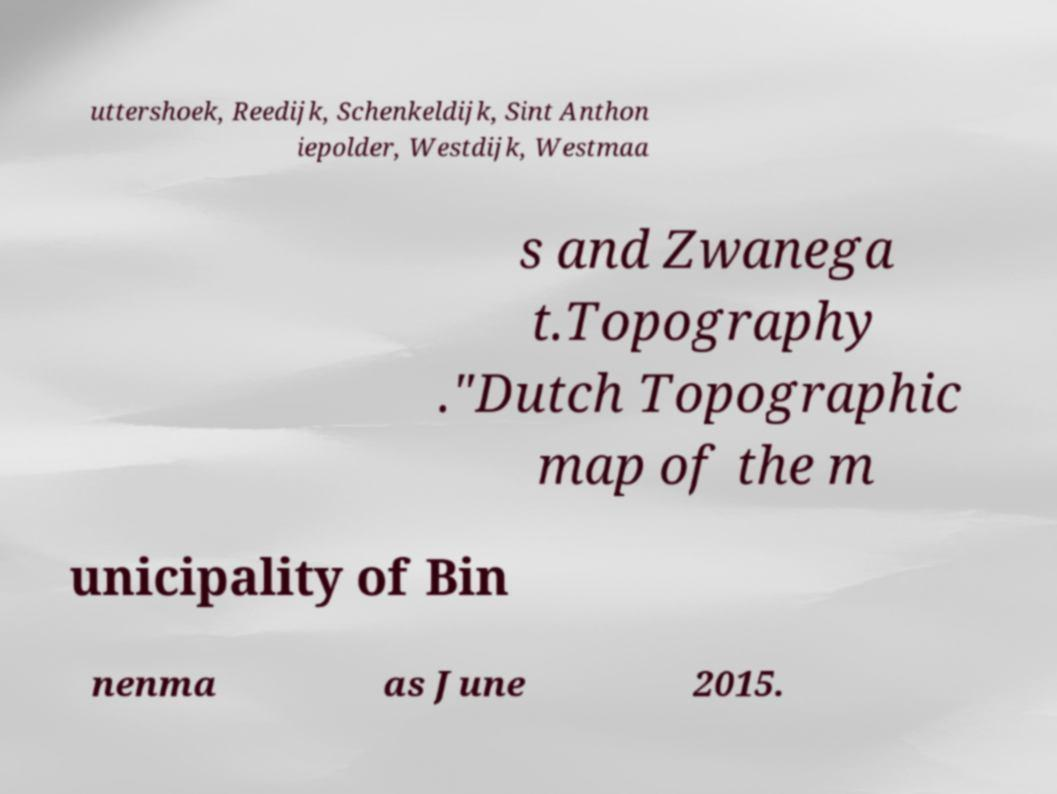Could you assist in decoding the text presented in this image and type it out clearly? uttershoek, Reedijk, Schenkeldijk, Sint Anthon iepolder, Westdijk, Westmaa s and Zwanega t.Topography ."Dutch Topographic map of the m unicipality of Bin nenma as June 2015. 